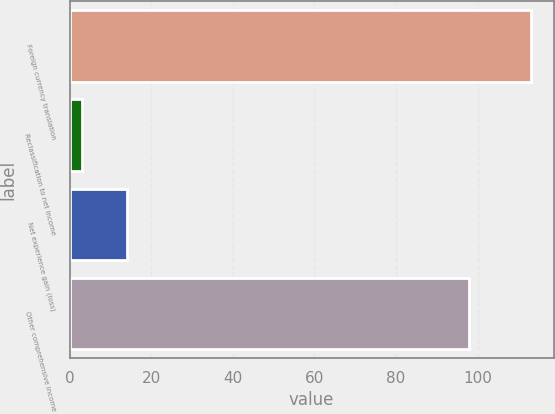<chart> <loc_0><loc_0><loc_500><loc_500><bar_chart><fcel>Foreign currency translation<fcel>Reclassification to net income<fcel>Net experience gain (loss)<fcel>Other comprehensive income<nl><fcel>113<fcel>3<fcel>14<fcel>98<nl></chart> 